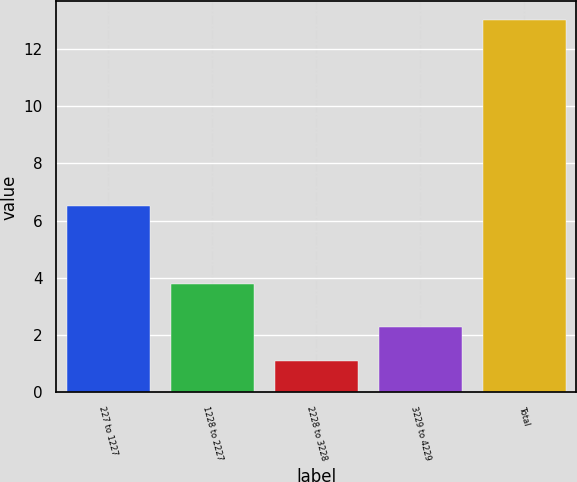<chart> <loc_0><loc_0><loc_500><loc_500><bar_chart><fcel>227 to 1227<fcel>1228 to 2227<fcel>2228 to 3228<fcel>3229 to 4229<fcel>Total<nl><fcel>6.5<fcel>3.8<fcel>1.1<fcel>2.29<fcel>13<nl></chart> 